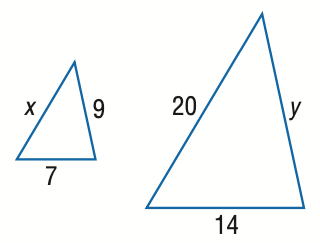Answer the mathemtical geometry problem and directly provide the correct option letter.
Question: Find x.
Choices: A: 5 B: 10 C: 15 D: 25 B 